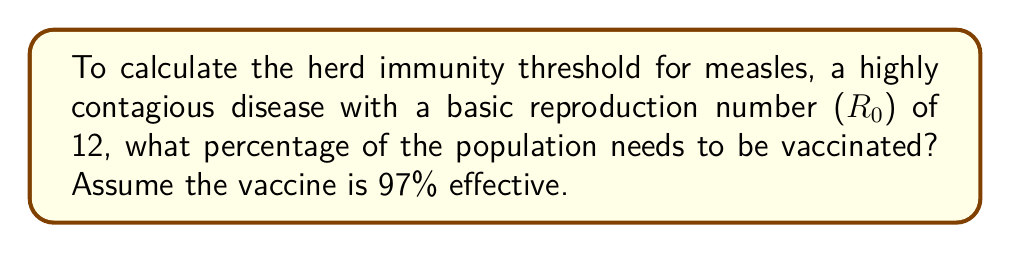Give your solution to this math problem. Let's approach this step-by-step:

1) The herd immunity threshold ($H$) is given by the formula:

   $$ H = 1 - \frac{1}{R_0} $$

   Where $R_0$ is the basic reproduction number.

2) For measles, $R_0 = 12$. Let's substitute this into our formula:

   $$ H = 1 - \frac{1}{12} = \frac{11}{12} \approx 0.9167 $$

3) This means that 91.67% of the population needs to be immune to achieve herd immunity.

4) However, the vaccine is not 100% effective. It's 97% effective. We need to account for this:

   Let $x$ be the proportion of the population that needs to be vaccinated.

   $$ 0.97x = 0.9167 $$

5) Solving for $x$:

   $$ x = \frac{0.9167}{0.97} \approx 0.9450 $$

6) Convert to a percentage:

   $$ 0.9450 \times 100\% = 94.50\% $$

Therefore, approximately 94.50% of the population needs to be vaccinated to achieve herd immunity for measles.
Answer: 94.50% 